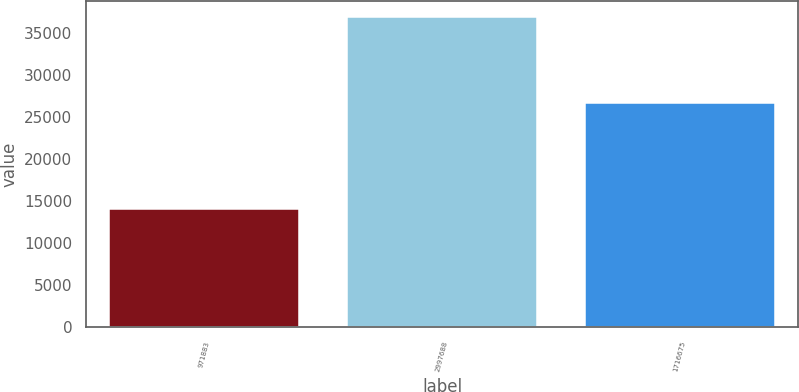<chart> <loc_0><loc_0><loc_500><loc_500><bar_chart><fcel>971883<fcel>2997688<fcel>1716675<nl><fcel>14087.8<fcel>36940.4<fcel>26624.8<nl></chart> 